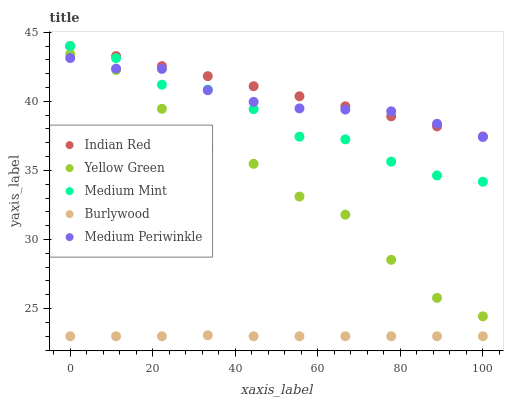Does Burlywood have the minimum area under the curve?
Answer yes or no. Yes. Does Indian Red have the maximum area under the curve?
Answer yes or no. Yes. Does Medium Periwinkle have the minimum area under the curve?
Answer yes or no. No. Does Medium Periwinkle have the maximum area under the curve?
Answer yes or no. No. Is Indian Red the smoothest?
Answer yes or no. Yes. Is Yellow Green the roughest?
Answer yes or no. Yes. Is Burlywood the smoothest?
Answer yes or no. No. Is Burlywood the roughest?
Answer yes or no. No. Does Burlywood have the lowest value?
Answer yes or no. Yes. Does Medium Periwinkle have the lowest value?
Answer yes or no. No. Does Indian Red have the highest value?
Answer yes or no. Yes. Does Medium Periwinkle have the highest value?
Answer yes or no. No. Is Burlywood less than Indian Red?
Answer yes or no. Yes. Is Yellow Green greater than Burlywood?
Answer yes or no. Yes. Does Medium Periwinkle intersect Indian Red?
Answer yes or no. Yes. Is Medium Periwinkle less than Indian Red?
Answer yes or no. No. Is Medium Periwinkle greater than Indian Red?
Answer yes or no. No. Does Burlywood intersect Indian Red?
Answer yes or no. No. 